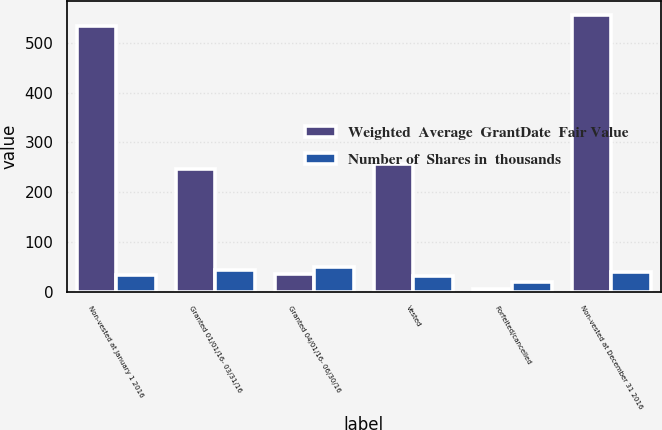Convert chart. <chart><loc_0><loc_0><loc_500><loc_500><stacked_bar_chart><ecel><fcel>Non-vested at January 1 2016<fcel>Granted 01/01/16- 03/31/16<fcel>Granted 04/01/16- 06/30/16<fcel>Vested<fcel>Forfeited/cancelled<fcel>Non-vested at December 31 2016<nl><fcel>Weighted  Average  GrantDate  Fair Value<fcel>535<fcel>246<fcel>36<fcel>256<fcel>5<fcel>556<nl><fcel>Number of  Shares in  thousands<fcel>33.19<fcel>43.99<fcel>49.65<fcel>31.5<fcel>19.42<fcel>39.95<nl></chart> 